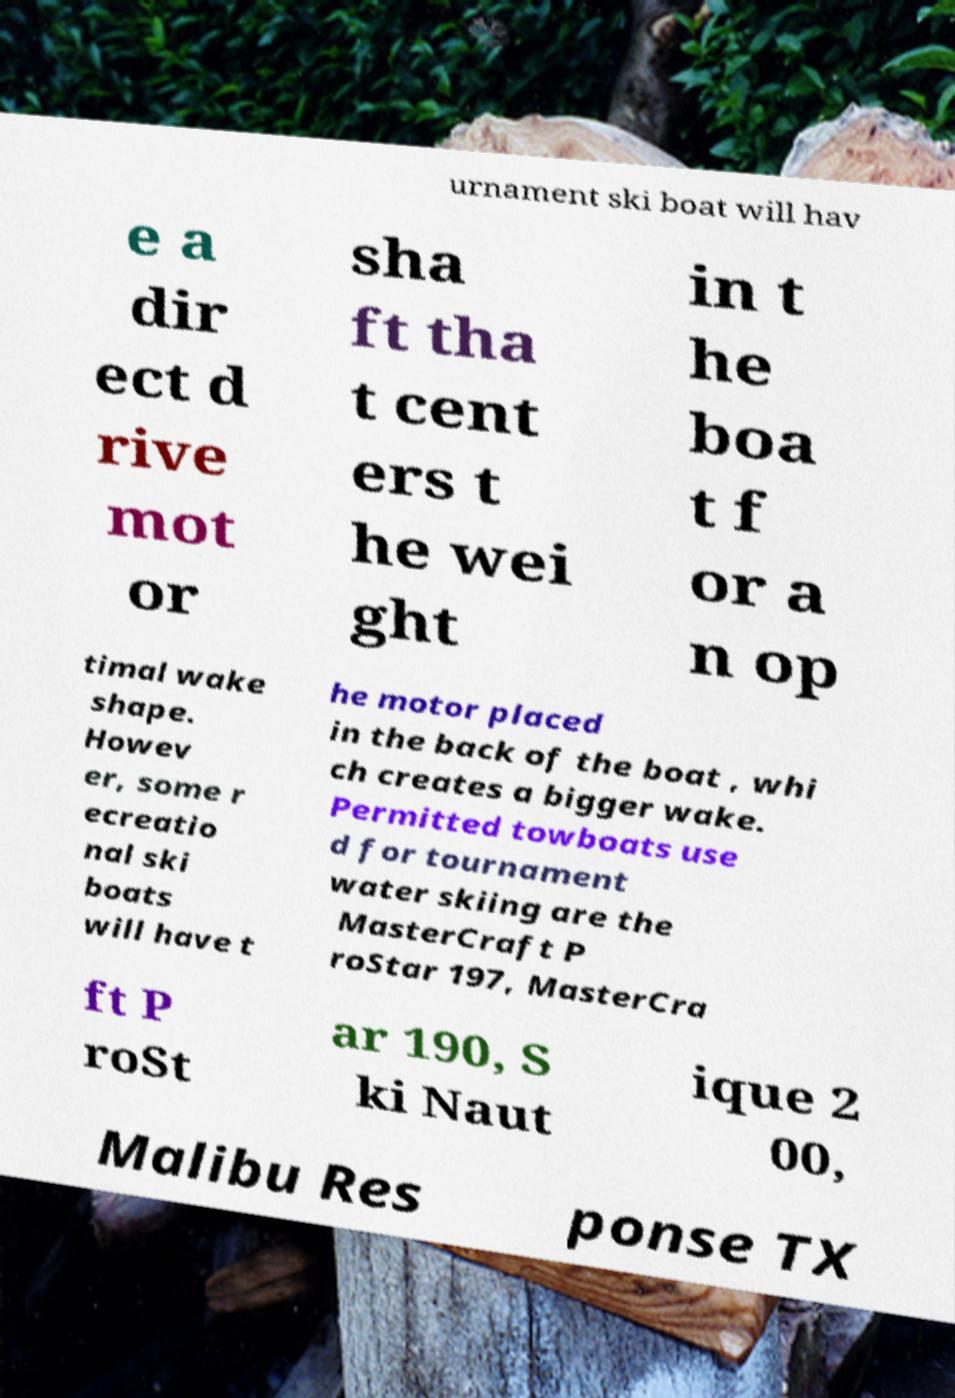Could you extract and type out the text from this image? urnament ski boat will hav e a dir ect d rive mot or sha ft tha t cent ers t he wei ght in t he boa t f or a n op timal wake shape. Howev er, some r ecreatio nal ski boats will have t he motor placed in the back of the boat , whi ch creates a bigger wake. Permitted towboats use d for tournament water skiing are the MasterCraft P roStar 197, MasterCra ft P roSt ar 190, S ki Naut ique 2 00, Malibu Res ponse TX 